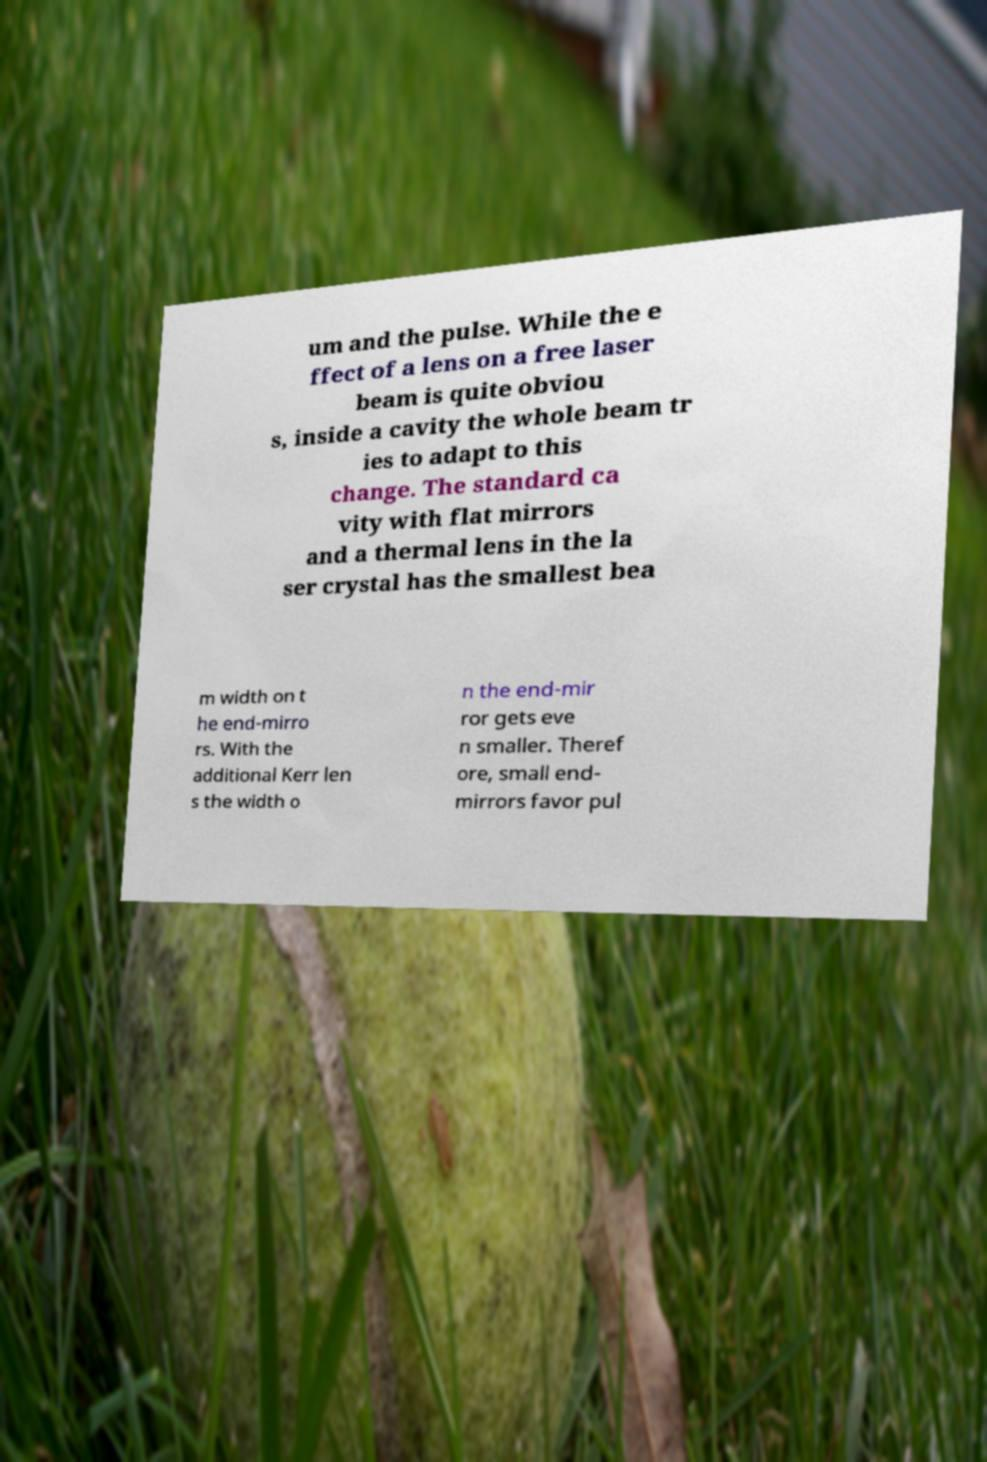Could you extract and type out the text from this image? um and the pulse. While the e ffect of a lens on a free laser beam is quite obviou s, inside a cavity the whole beam tr ies to adapt to this change. The standard ca vity with flat mirrors and a thermal lens in the la ser crystal has the smallest bea m width on t he end-mirro rs. With the additional Kerr len s the width o n the end-mir ror gets eve n smaller. Theref ore, small end- mirrors favor pul 